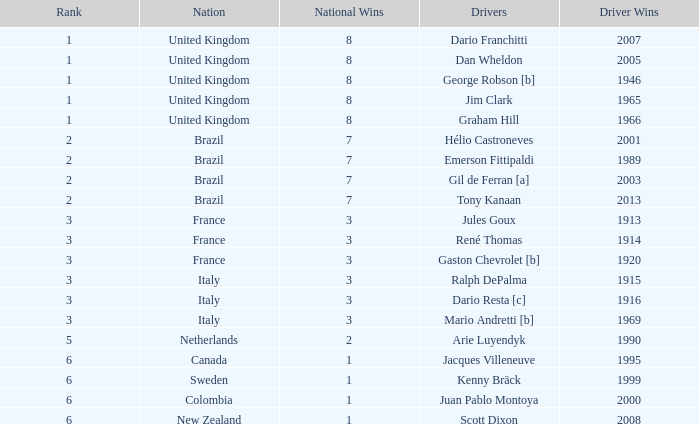What is the average number of wins of drivers from Sweden? 1999.0. 